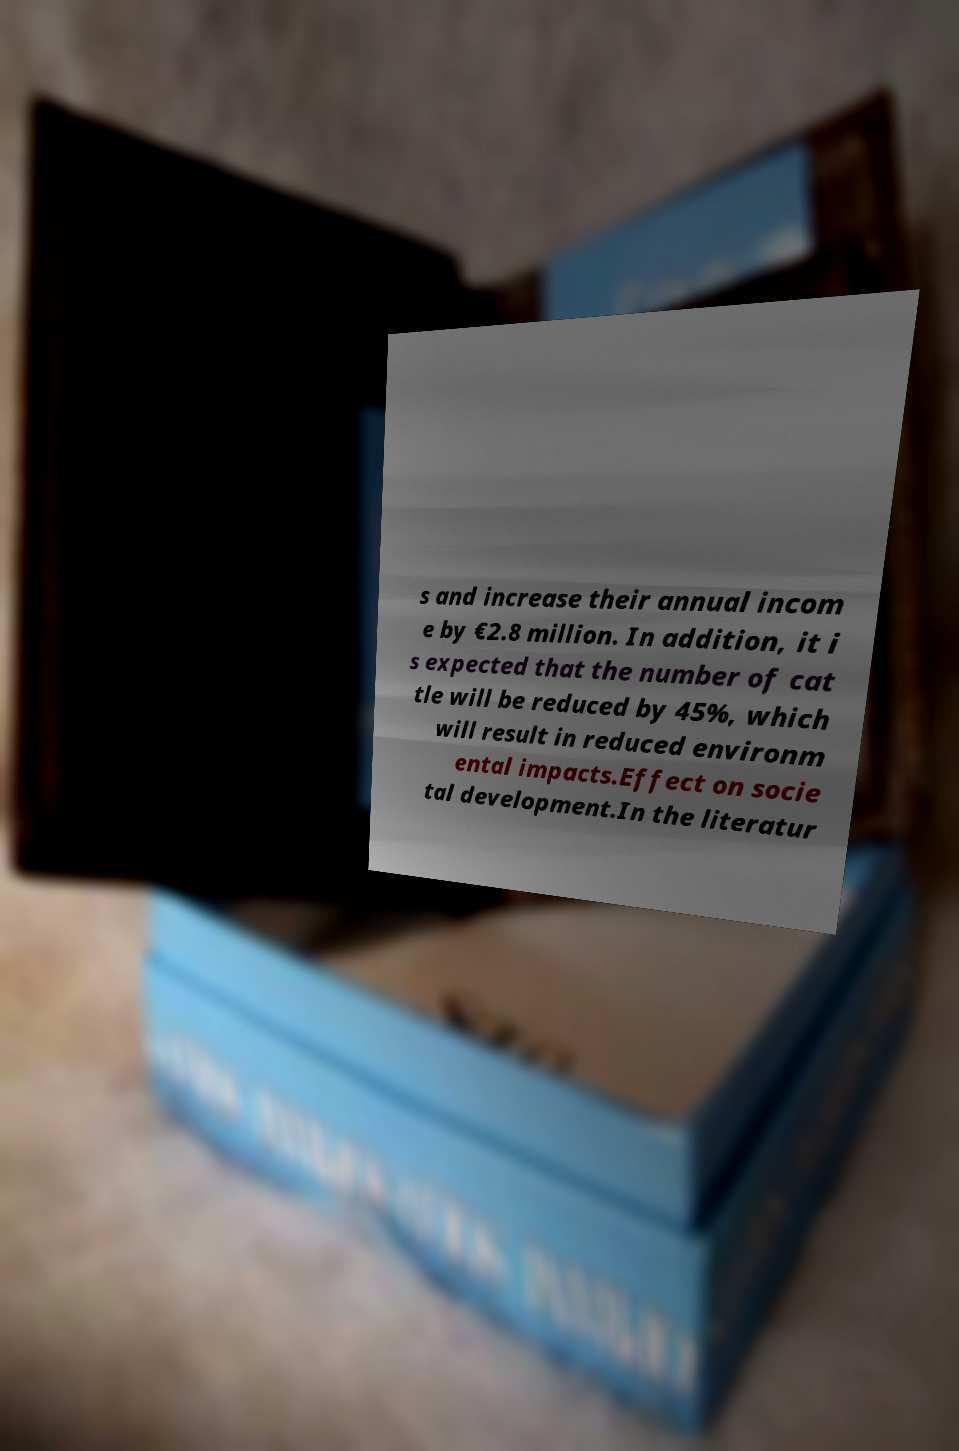I need the written content from this picture converted into text. Can you do that? s and increase their annual incom e by €2.8 million. In addition, it i s expected that the number of cat tle will be reduced by 45%, which will result in reduced environm ental impacts.Effect on socie tal development.In the literatur 